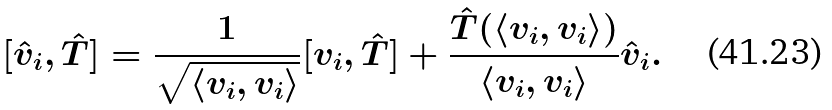<formula> <loc_0><loc_0><loc_500><loc_500>[ \hat { v } _ { i } , \hat { T } ] = \frac { 1 } { \sqrt { \langle v _ { i } , v _ { i } \rangle } } [ v _ { i } , \hat { T } ] + \frac { \hat { T } ( \langle v _ { i } , v _ { i } \rangle ) } { \langle v _ { i } , v _ { i } \rangle } \hat { v } _ { i } .</formula> 